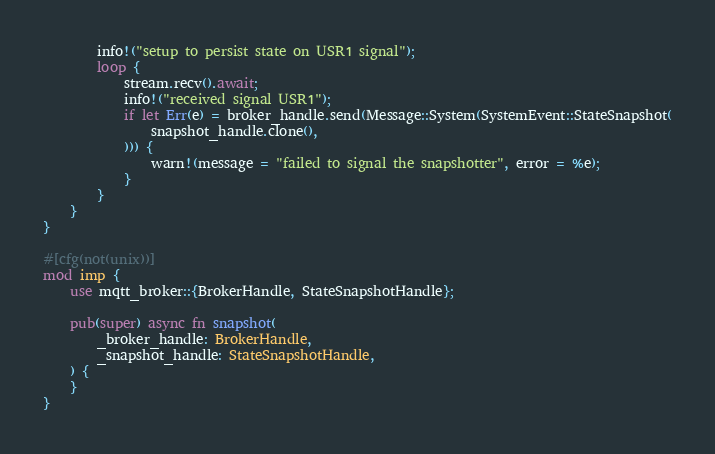<code> <loc_0><loc_0><loc_500><loc_500><_Rust_>
        info!("setup to persist state on USR1 signal");
        loop {
            stream.recv().await;
            info!("received signal USR1");
            if let Err(e) = broker_handle.send(Message::System(SystemEvent::StateSnapshot(
                snapshot_handle.clone(),
            ))) {
                warn!(message = "failed to signal the snapshotter", error = %e);
            }
        }
    }
}

#[cfg(not(unix))]
mod imp {
    use mqtt_broker::{BrokerHandle, StateSnapshotHandle};

    pub(super) async fn snapshot(
        _broker_handle: BrokerHandle,
        _snapshot_handle: StateSnapshotHandle,
    ) {
    }
}
</code> 